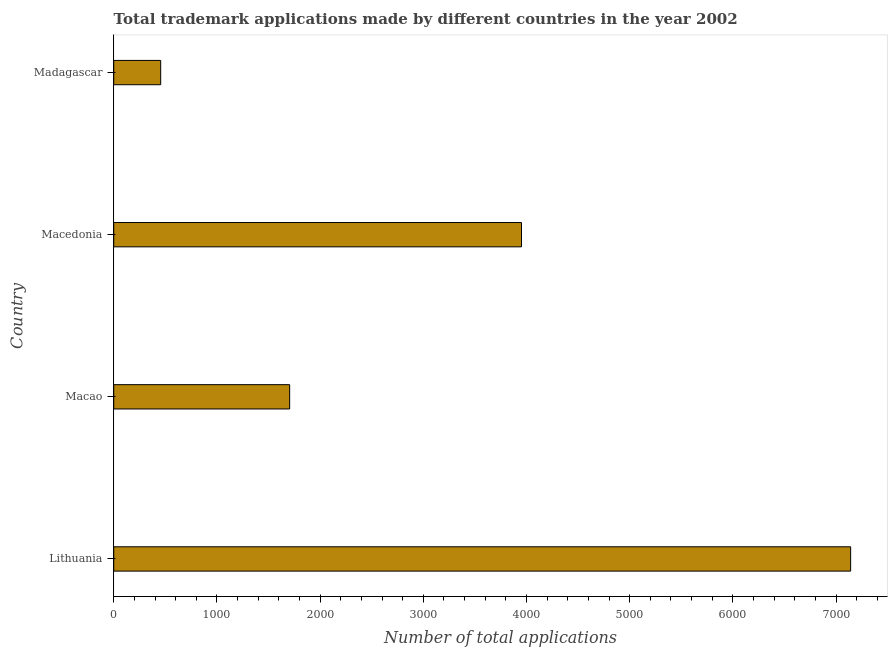Does the graph contain any zero values?
Keep it short and to the point. No. Does the graph contain grids?
Your answer should be very brief. No. What is the title of the graph?
Your response must be concise. Total trademark applications made by different countries in the year 2002. What is the label or title of the X-axis?
Provide a succinct answer. Number of total applications. What is the number of trademark applications in Madagascar?
Your answer should be very brief. 455. Across all countries, what is the maximum number of trademark applications?
Provide a short and direct response. 7142. Across all countries, what is the minimum number of trademark applications?
Keep it short and to the point. 455. In which country was the number of trademark applications maximum?
Provide a short and direct response. Lithuania. In which country was the number of trademark applications minimum?
Keep it short and to the point. Madagascar. What is the sum of the number of trademark applications?
Provide a succinct answer. 1.33e+04. What is the difference between the number of trademark applications in Macedonia and Madagascar?
Keep it short and to the point. 3497. What is the average number of trademark applications per country?
Your response must be concise. 3313. What is the median number of trademark applications?
Offer a very short reply. 2828.5. What is the ratio of the number of trademark applications in Macao to that in Macedonia?
Your response must be concise. 0.43. Is the number of trademark applications in Macao less than that in Madagascar?
Offer a very short reply. No. What is the difference between the highest and the second highest number of trademark applications?
Provide a short and direct response. 3190. Is the sum of the number of trademark applications in Lithuania and Macao greater than the maximum number of trademark applications across all countries?
Your answer should be very brief. Yes. What is the difference between the highest and the lowest number of trademark applications?
Offer a terse response. 6687. How many countries are there in the graph?
Your answer should be compact. 4. What is the difference between two consecutive major ticks on the X-axis?
Make the answer very short. 1000. Are the values on the major ticks of X-axis written in scientific E-notation?
Make the answer very short. No. What is the Number of total applications in Lithuania?
Keep it short and to the point. 7142. What is the Number of total applications of Macao?
Make the answer very short. 1705. What is the Number of total applications of Macedonia?
Give a very brief answer. 3952. What is the Number of total applications of Madagascar?
Ensure brevity in your answer.  455. What is the difference between the Number of total applications in Lithuania and Macao?
Ensure brevity in your answer.  5437. What is the difference between the Number of total applications in Lithuania and Macedonia?
Your response must be concise. 3190. What is the difference between the Number of total applications in Lithuania and Madagascar?
Ensure brevity in your answer.  6687. What is the difference between the Number of total applications in Macao and Macedonia?
Provide a short and direct response. -2247. What is the difference between the Number of total applications in Macao and Madagascar?
Your answer should be very brief. 1250. What is the difference between the Number of total applications in Macedonia and Madagascar?
Offer a terse response. 3497. What is the ratio of the Number of total applications in Lithuania to that in Macao?
Make the answer very short. 4.19. What is the ratio of the Number of total applications in Lithuania to that in Macedonia?
Make the answer very short. 1.81. What is the ratio of the Number of total applications in Lithuania to that in Madagascar?
Your response must be concise. 15.7. What is the ratio of the Number of total applications in Macao to that in Macedonia?
Give a very brief answer. 0.43. What is the ratio of the Number of total applications in Macao to that in Madagascar?
Your answer should be compact. 3.75. What is the ratio of the Number of total applications in Macedonia to that in Madagascar?
Offer a terse response. 8.69. 